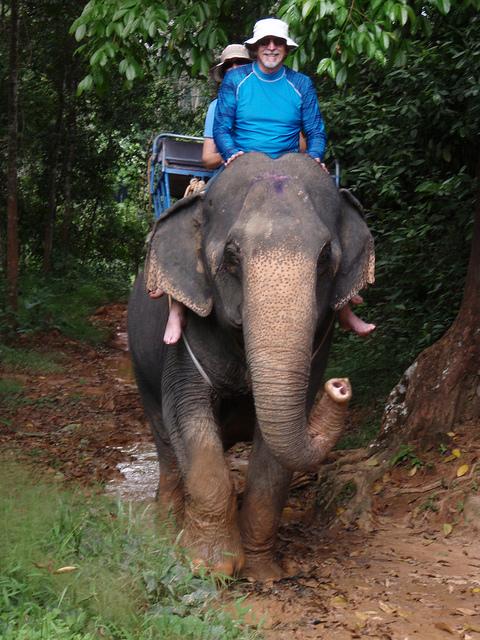What color is the elephant's trunk?
Quick response, please. Brown. Why is the man smiling?
Be succinct. Riding elephant. Is the man wearing a hat?
Answer briefly. Yes. How many people are on the animal?
Write a very short answer. 2. 